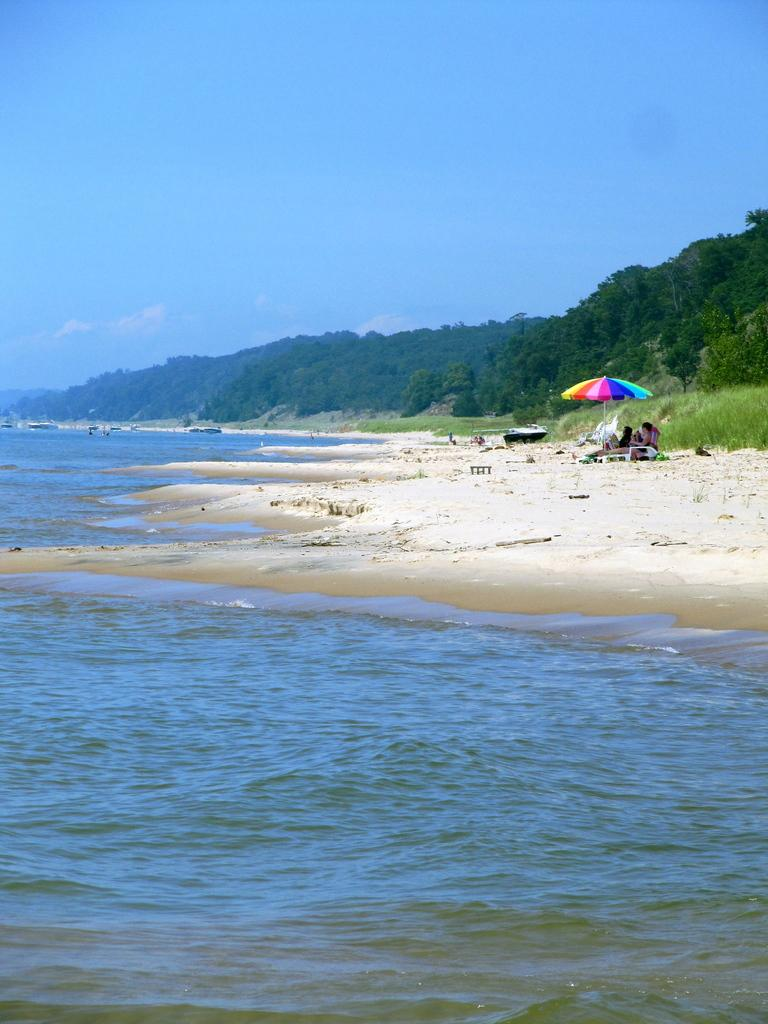What are the people in the image doing? There is a group of people sitting in the image. What object can be seen in the image that provides shade or protection from the elements? There is a multi-color umbrella in the image. What natural element is visible in the image? There is water visible in the image. What type of vegetation can be seen in the image? There are trees with green color in the image. What is the color of the sky in the image? The sky is blue in the image. What theory is being discussed by the people sitting under the umbrella in the image? There is no indication in the image that the people are discussing any theory. 